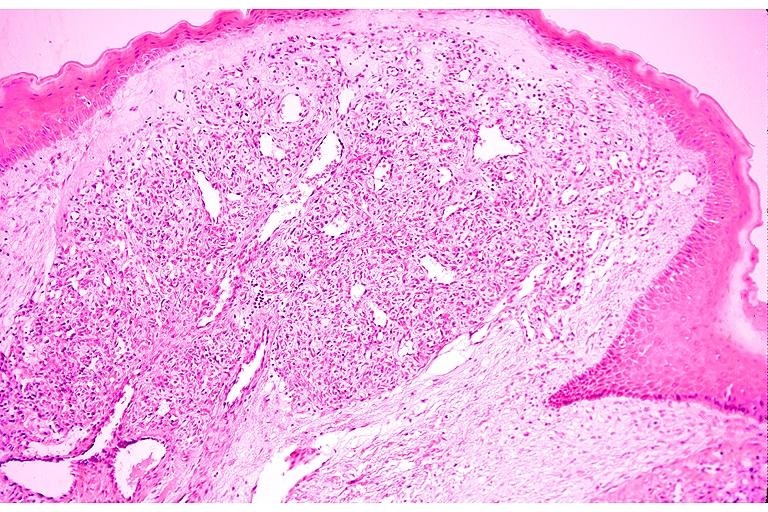what does this image show?
Answer the question using a single word or phrase. Capillary hemangioma 